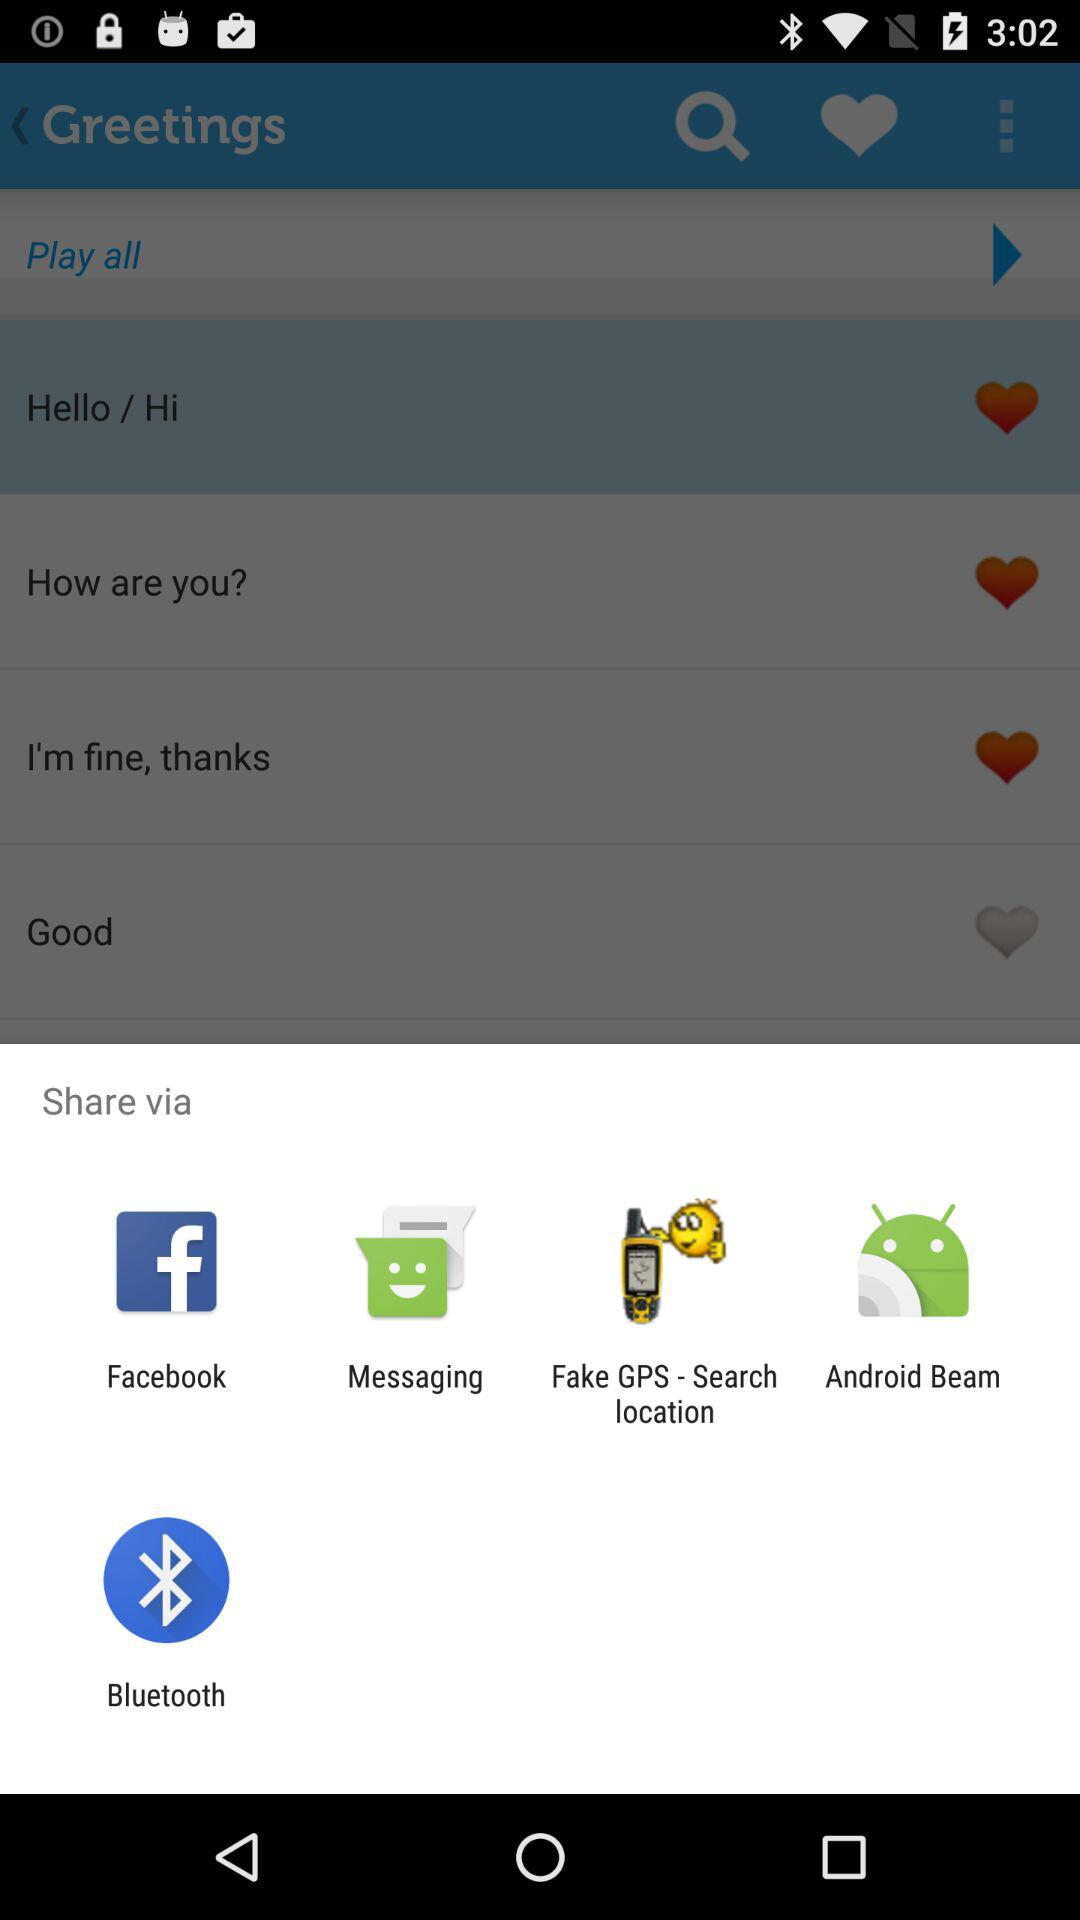What are the available sharing options? The available sharing options are "Facebook", "Messaging", "Fake GPS - Search location", "Android Beam" and "Bluetooth". 